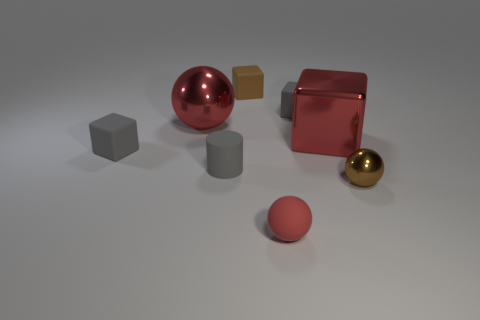Add 2 big blocks. How many objects exist? 10 Subtract all spheres. How many objects are left? 5 Subtract all tiny red rubber spheres. Subtract all large red metal objects. How many objects are left? 5 Add 3 matte balls. How many matte balls are left? 4 Add 5 small brown objects. How many small brown objects exist? 7 Subtract 0 gray spheres. How many objects are left? 8 